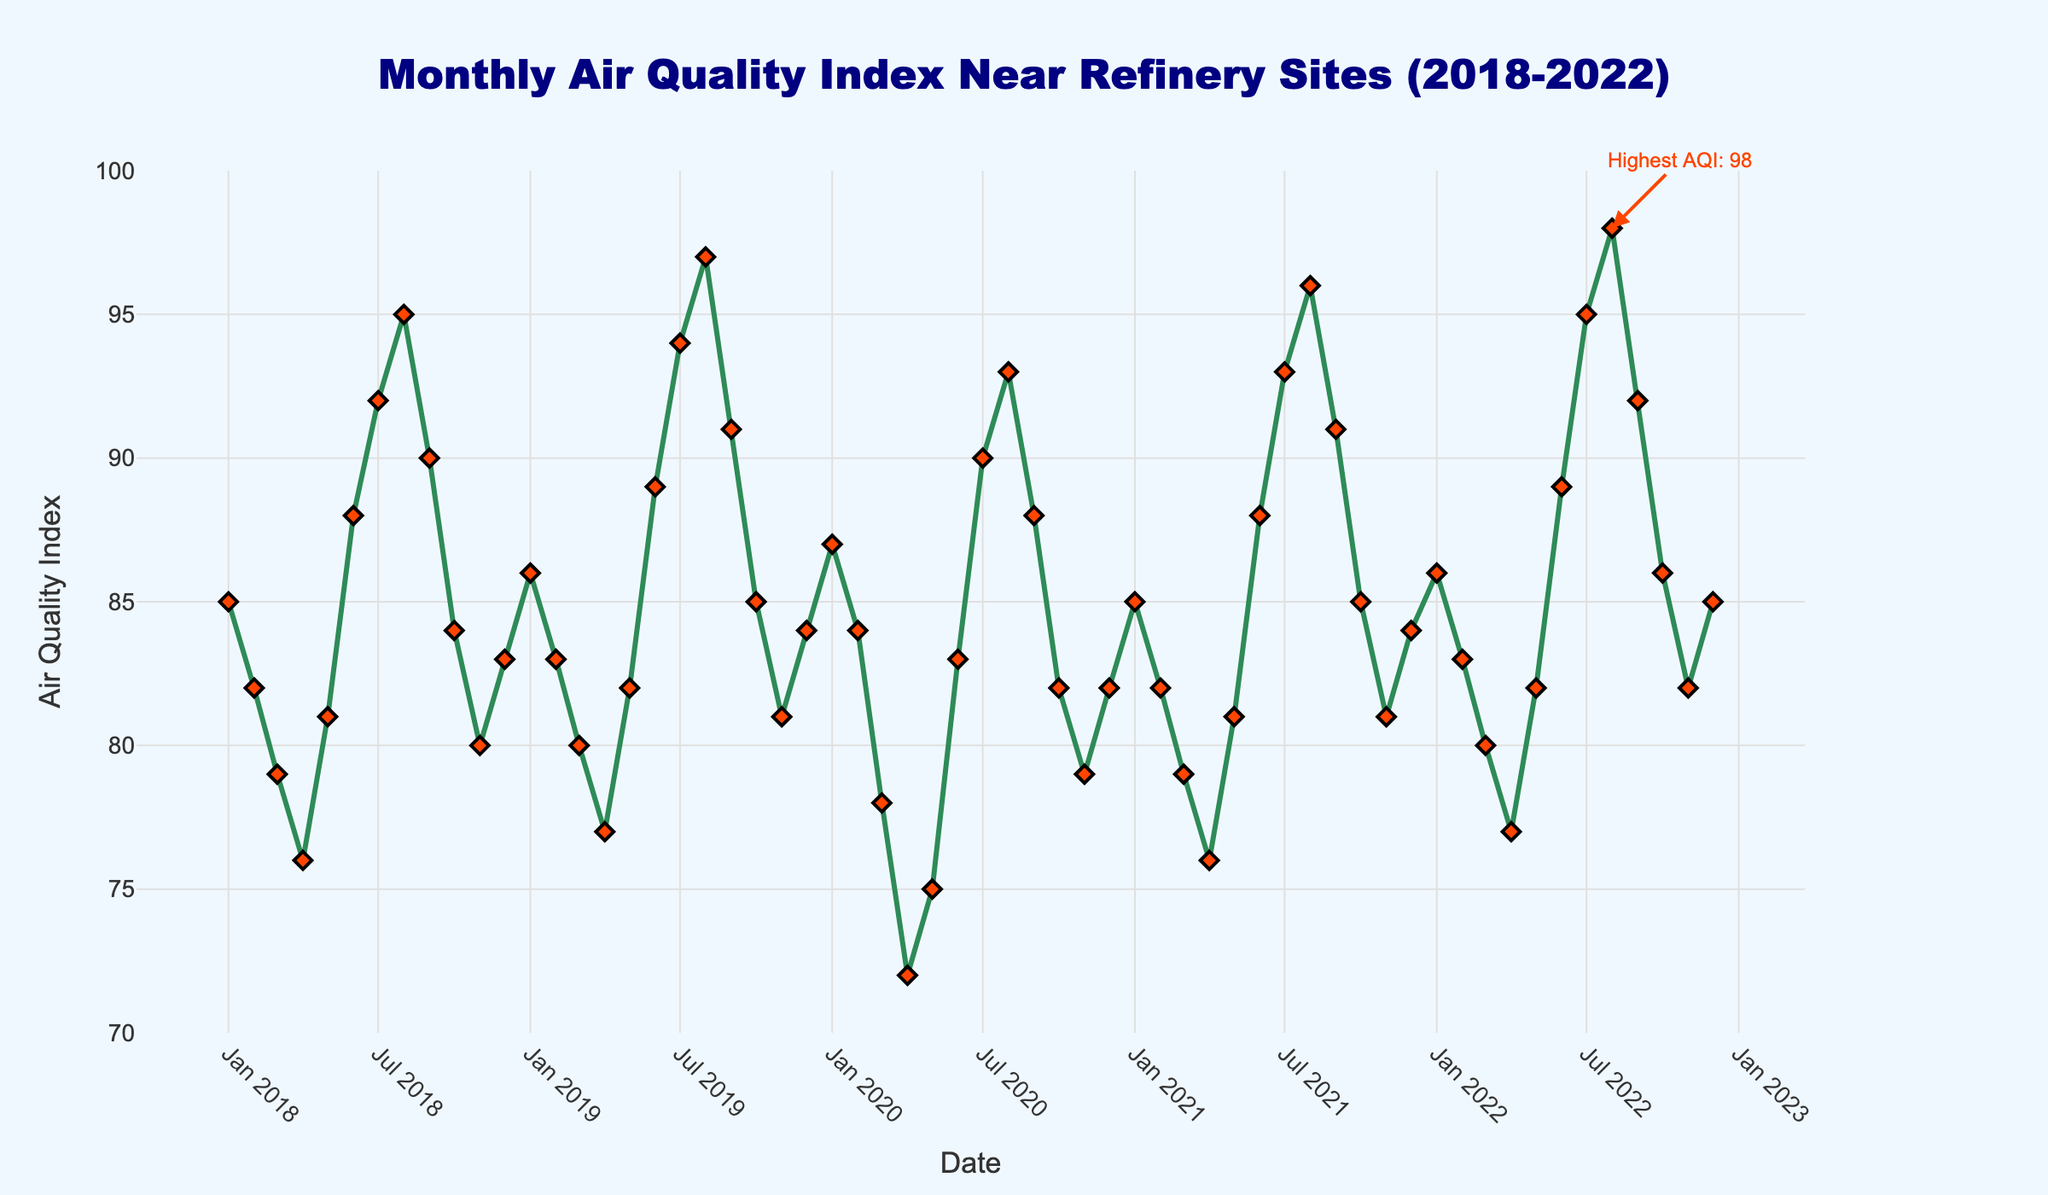What month and year had the highest Air Quality Index (AQI), and what was the value? The annotation in the plot indicates the highest AQI value. The marker and annotation point to the specific date and value.
Answer: August 2022, 98 How does the AQI in July 2019 compare to July 2021? Refer to the data points for July 2019 and July 2021 and compare their AQI values. July 2019 shows an AQI of 94, while July 2021 shows an AQI of 93.
Answer: July 2019 is higher by 1 What is the difference in AQI between January 2018 and January 2022? Locate the data points for January 2018 and January 2022 and calculate the difference in AQI values. January 2018 has an AQI of 85, and January 2022 has an AQI of 86. The difference is 86 - 85.
Answer: 1 What is the average AQI for the months January through March over the 5-year period? Calculate the average AQI for each month (January, February, and March) across all years, then average these values. Add AQI values for each year for January, February, and March, then average the sums: (85+86+87+85+86) + (82+83+84+82+83) + (79+80+78+79+80) = 86(5) + 82.5(5) + 79(5) = 85.5
Answer: 85.5 Which year shows the most improvement in AQI from January to December? Compare the AQI of January versus December for each year and find the year with the largest positive difference. Subtract January value from December value for each year and compare results.
Answer: 2020, decrease of 5 Between June 2019 and June 2020, did the AQI improve or worsen? By how much? Find the data points for June 2019 and June 2020, compare the AQI values, and calculate the difference. June 2019 shows an AQI of 89, while June 2020 has an AQI of 83. The difference is 89 - 83.
Answer: Improved by 6 What trends can you observe in the AQI during the summer months (June, July, August) over the 5-year period? Evaluate the AQI values for June, July, and August for each year, looking for patterns or trends. Notably, values consistently increase during summer months with peaks often in July or August.
Answer: Increasing trend 